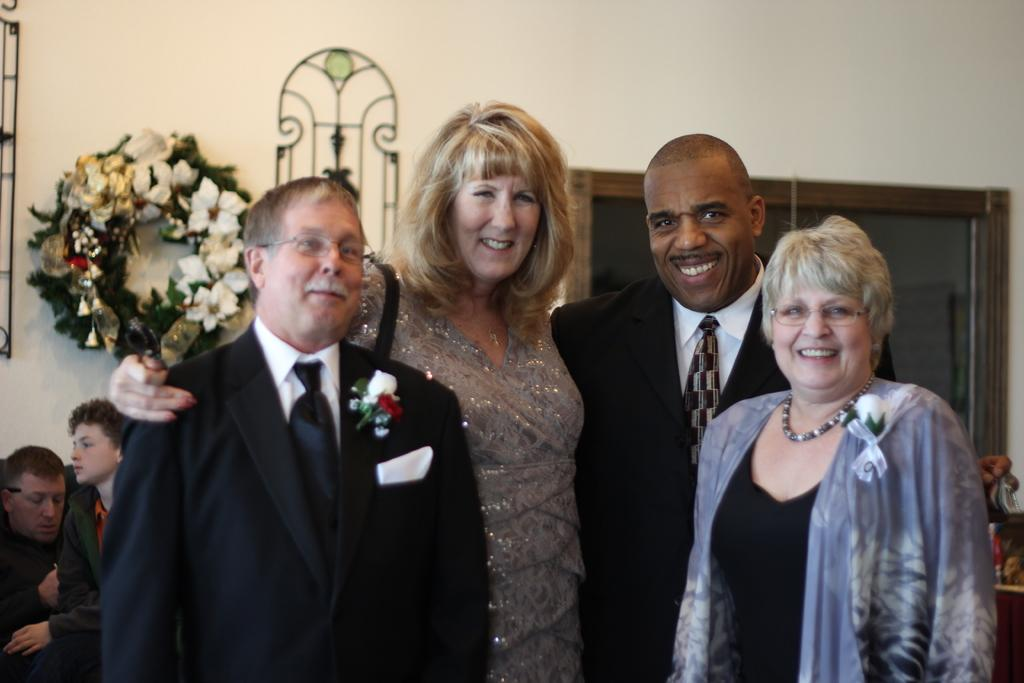How many people are in the image? There are people in the image, but the exact number is not specified. What are the people in the front doing? The people in the front are standing and smiling. What can be seen in the background of the image? There are flowers and objects attached to the wall in the background of the image. What type of books can be seen in the library in the image? There is no library or books present in the image. What is the occupation of the farmer in the image? There is no farmer present in the image. 